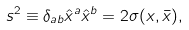<formula> <loc_0><loc_0><loc_500><loc_500>s ^ { 2 } \equiv \delta _ { a b } \hat { x } ^ { a } \hat { x } ^ { b } = 2 \sigma ( x , \bar { x } ) ,</formula> 